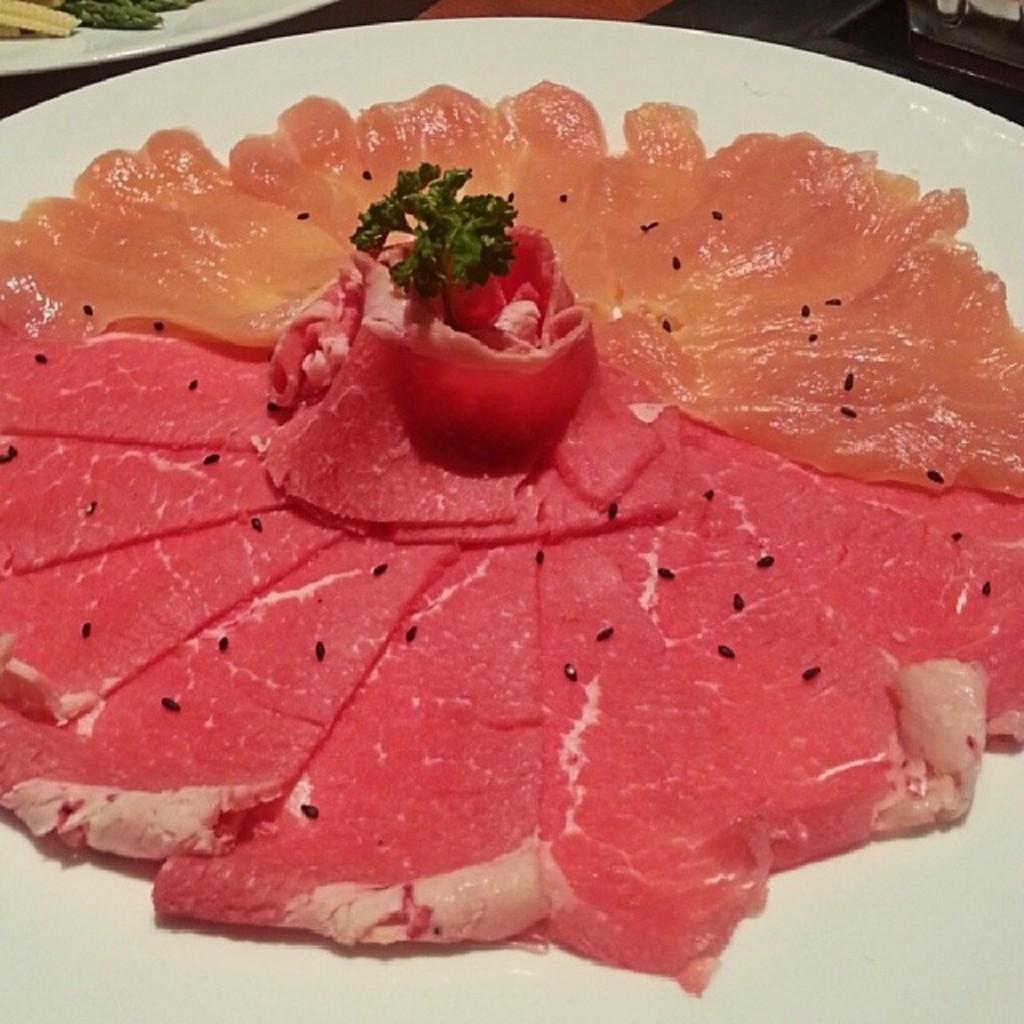Describe this image in one or two sentences. In this image there is a plate on which there is meat at the bottom, Beside the meat there is jelly. It is in the form of a flower. 